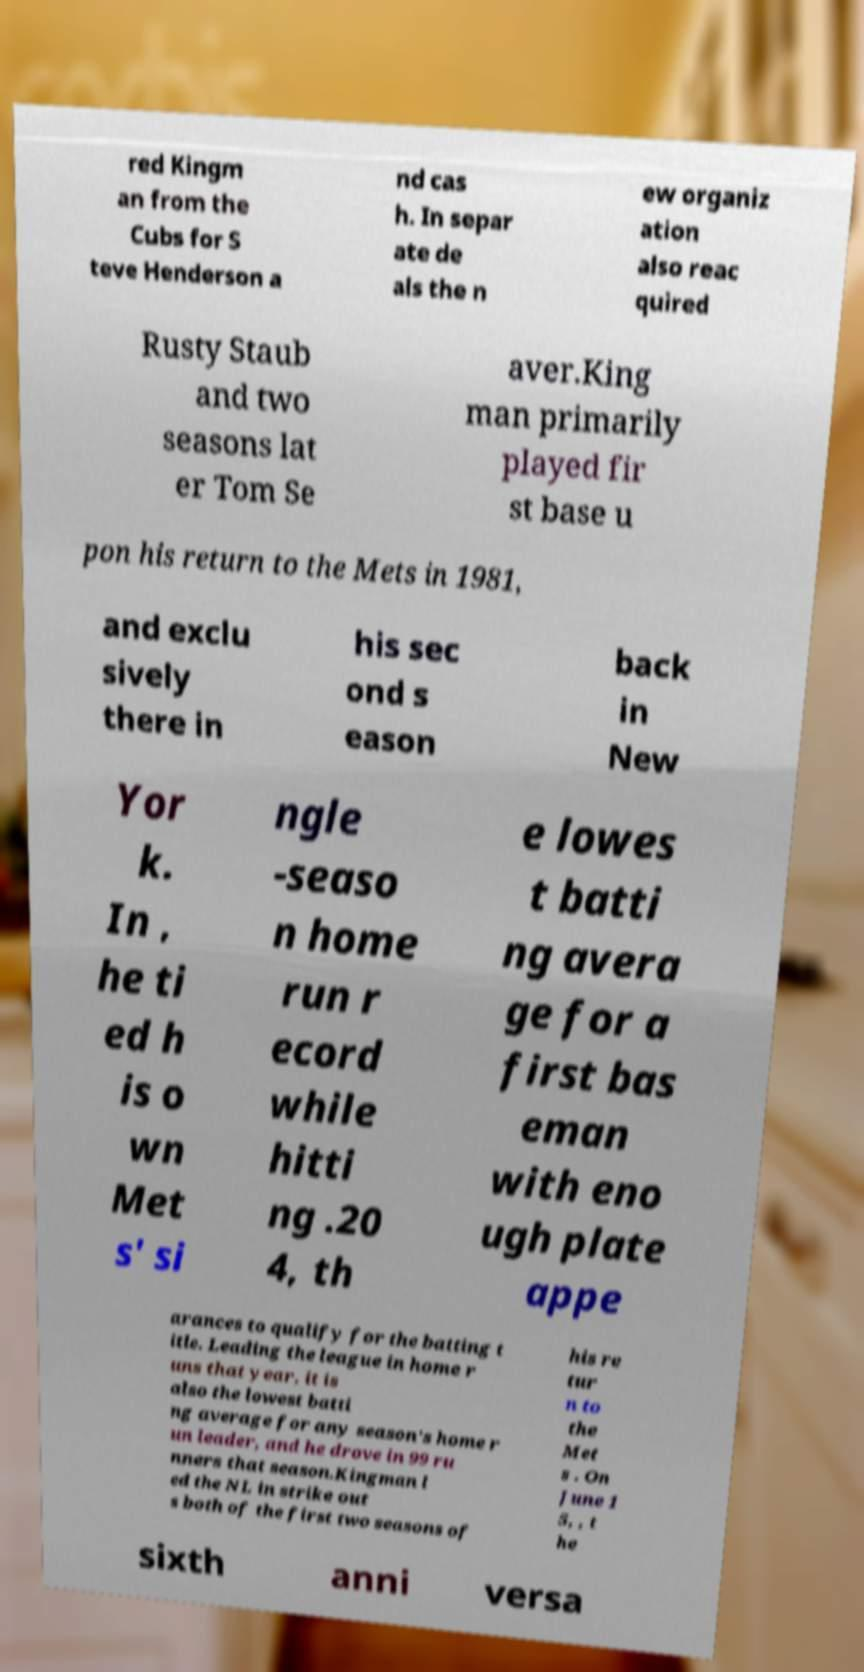Could you assist in decoding the text presented in this image and type it out clearly? red Kingm an from the Cubs for S teve Henderson a nd cas h. In separ ate de als the n ew organiz ation also reac quired Rusty Staub and two seasons lat er Tom Se aver.King man primarily played fir st base u pon his return to the Mets in 1981, and exclu sively there in his sec ond s eason back in New Yor k. In , he ti ed h is o wn Met s' si ngle -seaso n home run r ecord while hitti ng .20 4, th e lowes t batti ng avera ge for a first bas eman with eno ugh plate appe arances to qualify for the batting t itle. Leading the league in home r uns that year, it is also the lowest batti ng average for any season's home r un leader, and he drove in 99 ru nners that season.Kingman l ed the NL in strike out s both of the first two seasons of his re tur n to the Met s . On June 1 5, , t he sixth anni versa 